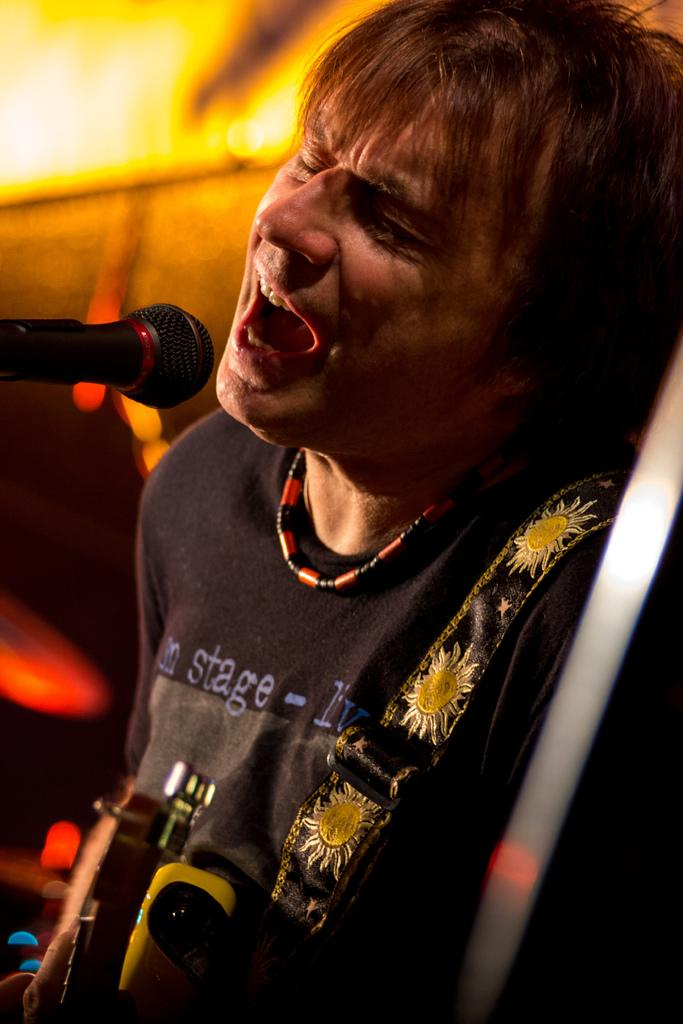What is the man in the image doing? The man is playing a guitar and singing. What object is in front of the man? There is a microphone in front of the man. What can be seen in the background of the image? There are lights visible in the background. What type of silver is the beggar holding in the image? There is no beggar or silver present in the image. How many guitars is the man playing in the image? The man is playing only one guitar in the image. 